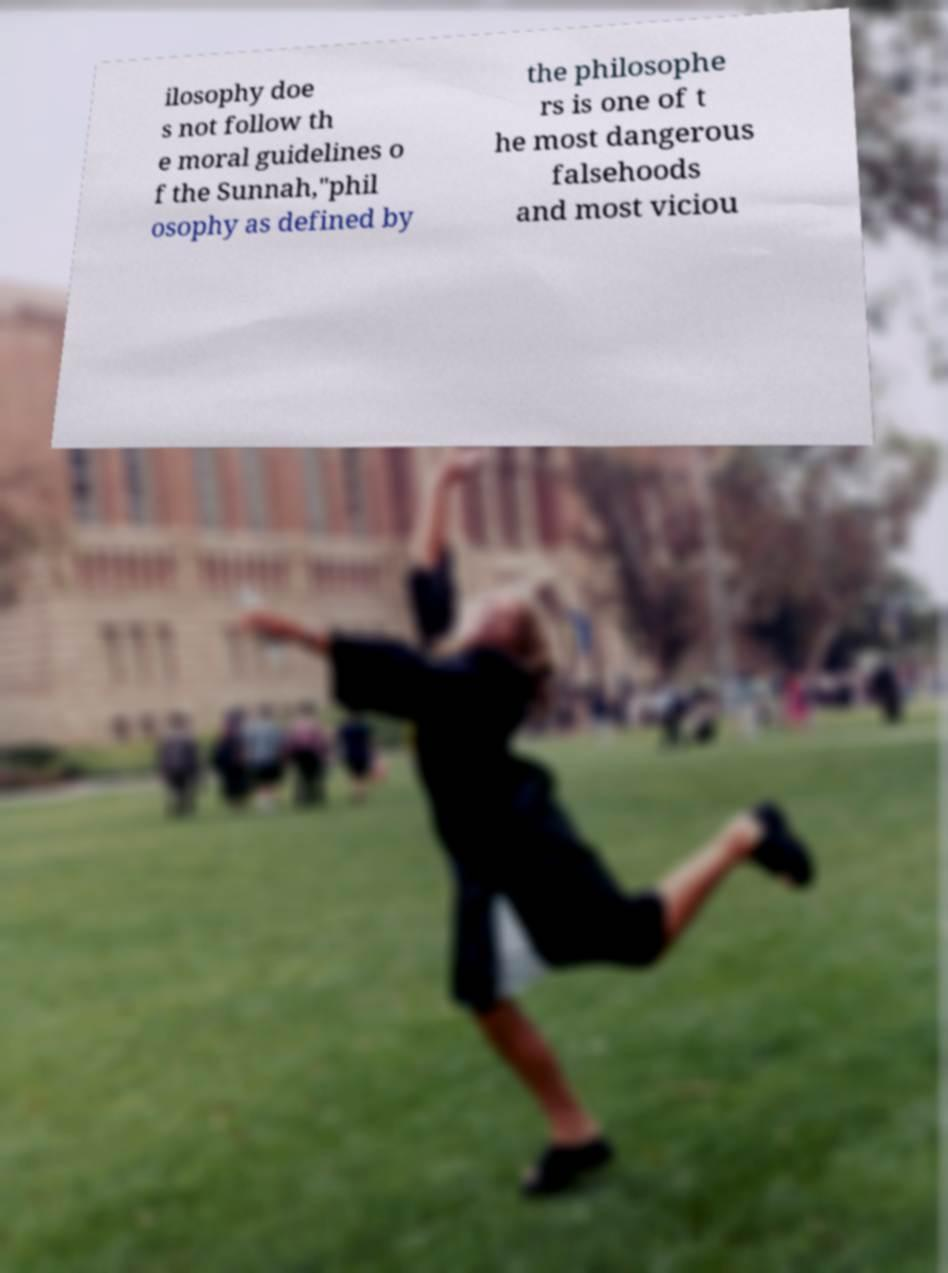Please identify and transcribe the text found in this image. ilosophy doe s not follow th e moral guidelines o f the Sunnah,"phil osophy as defined by the philosophe rs is one of t he most dangerous falsehoods and most viciou 